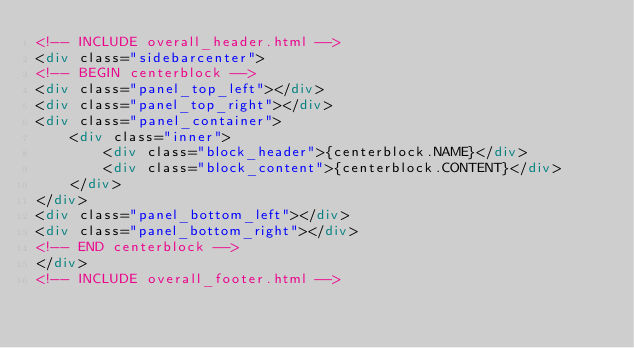<code> <loc_0><loc_0><loc_500><loc_500><_HTML_><!-- INCLUDE overall_header.html -->
<div class="sidebarcenter">
<!-- BEGIN centerblock -->
<div class="panel_top_left"></div>
<div class="panel_top_right"></div>
<div class="panel_container">
	<div class="inner">
		<div class="block_header">{centerblock.NAME}</div>
		<div class="block_content">{centerblock.CONTENT}</div>
	</div>
</div>
<div class="panel_bottom_left"></div>
<div class="panel_bottom_right"></div>
<!-- END centerblock -->
</div>
<!-- INCLUDE overall_footer.html -->
</code> 